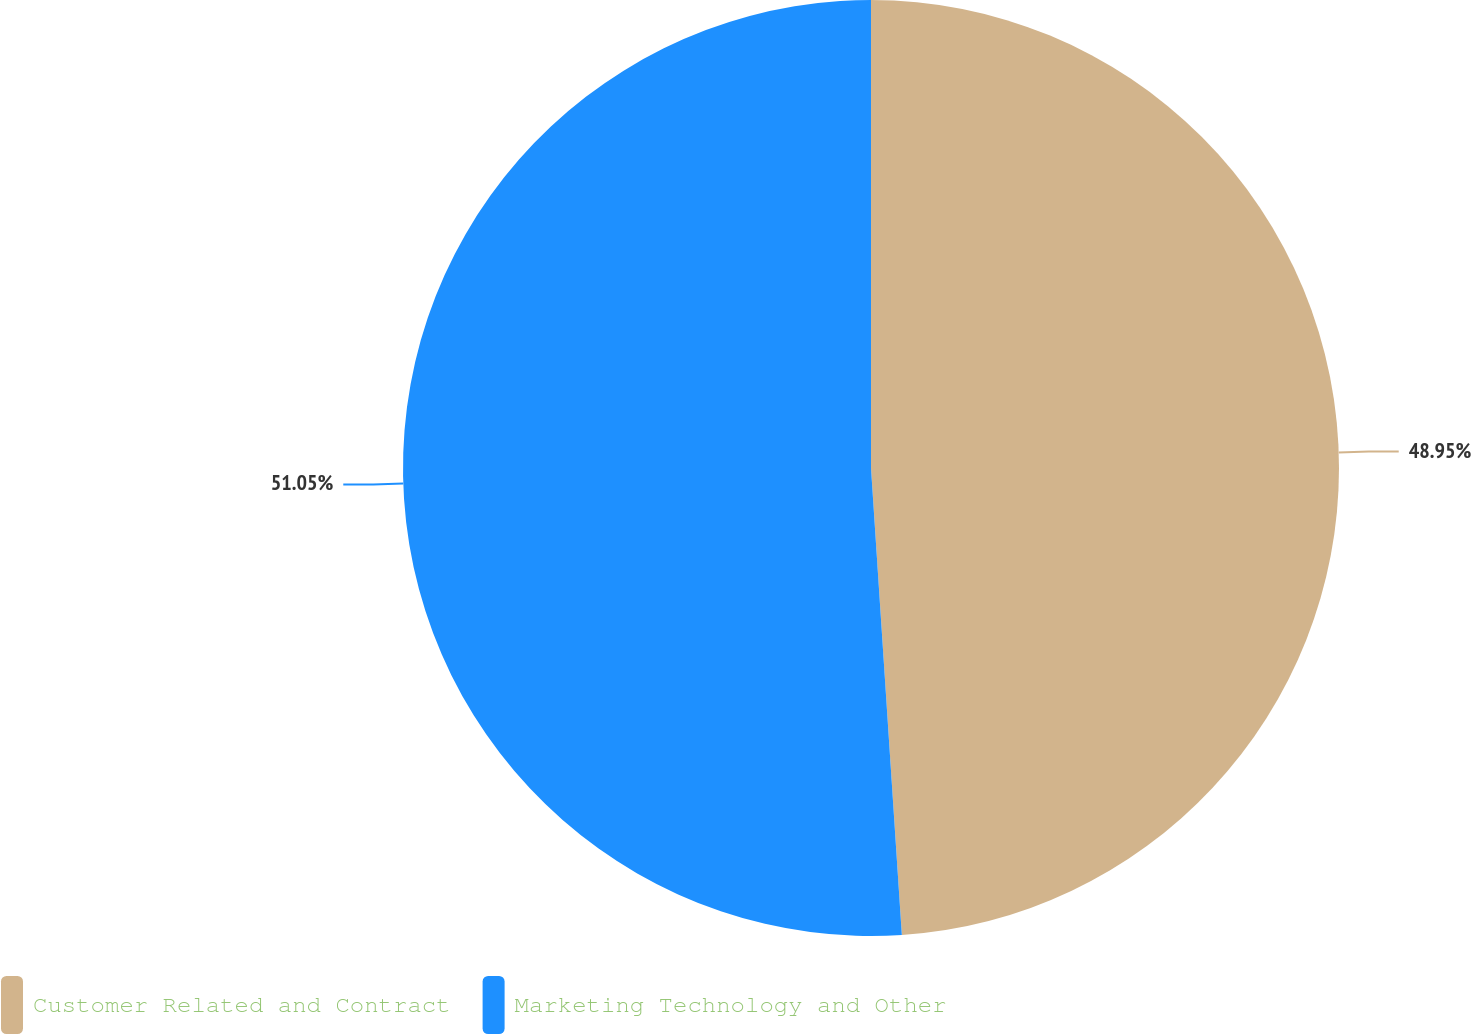Convert chart to OTSL. <chart><loc_0><loc_0><loc_500><loc_500><pie_chart><fcel>Customer Related and Contract<fcel>Marketing Technology and Other<nl><fcel>48.95%<fcel>51.05%<nl></chart> 